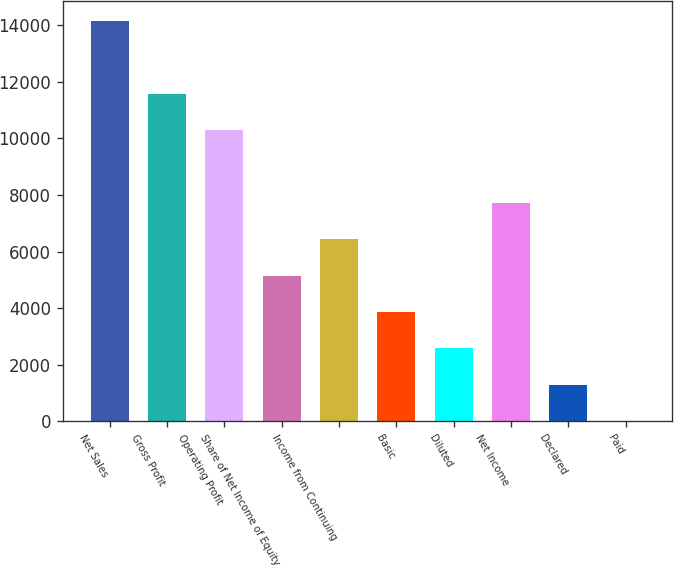<chart> <loc_0><loc_0><loc_500><loc_500><bar_chart><fcel>Net Sales<fcel>Gross Profit<fcel>Operating Profit<fcel>Share of Net Income of Equity<fcel>Income from Continuing<fcel>Basic<fcel>Diluted<fcel>Net Income<fcel>Declared<fcel>Paid<nl><fcel>14152.1<fcel>11579.2<fcel>10292.7<fcel>5146.87<fcel>6433.33<fcel>3860.41<fcel>2573.95<fcel>7719.79<fcel>1287.49<fcel>1.03<nl></chart> 